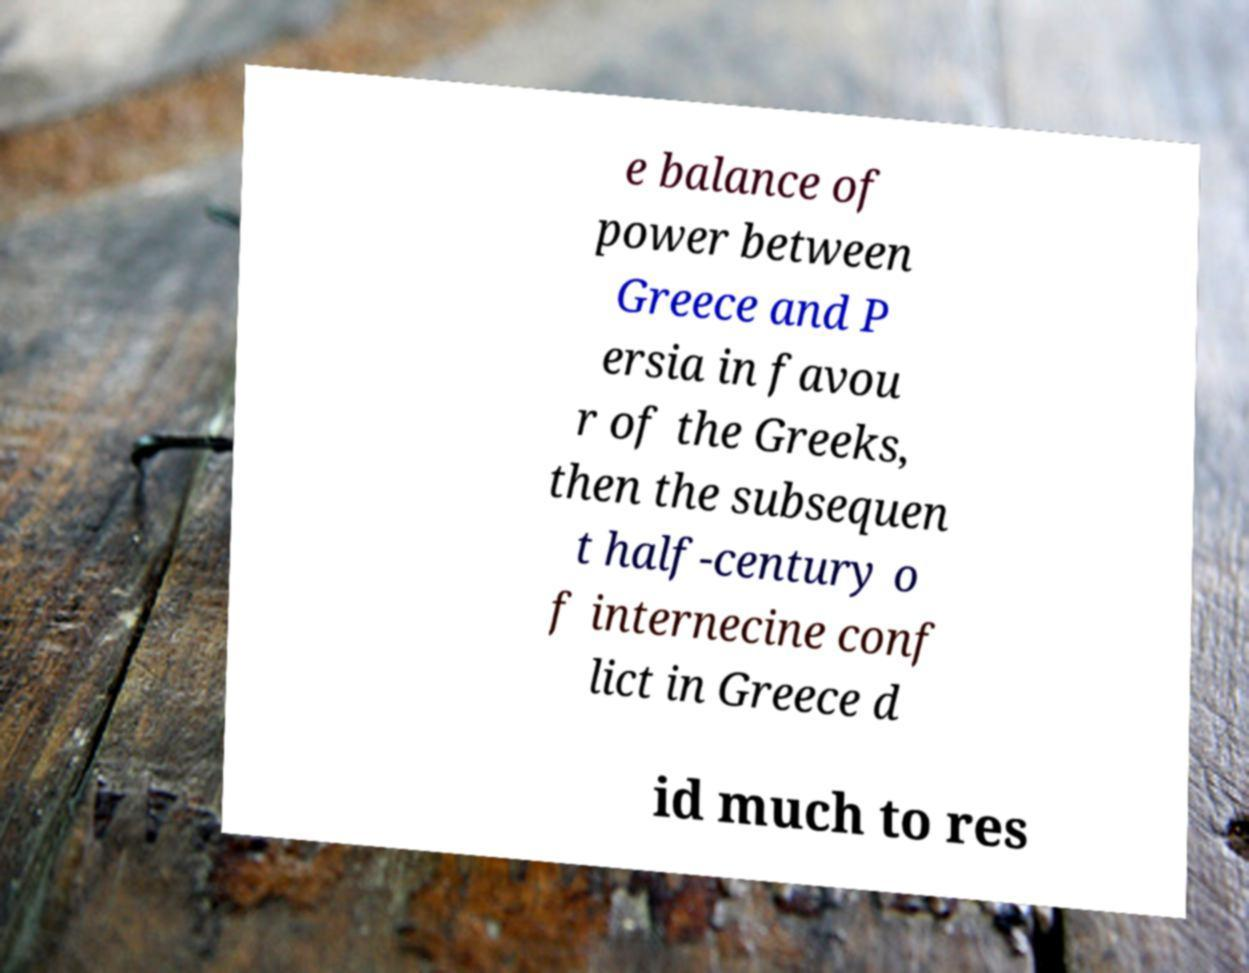Can you accurately transcribe the text from the provided image for me? e balance of power between Greece and P ersia in favou r of the Greeks, then the subsequen t half-century o f internecine conf lict in Greece d id much to res 